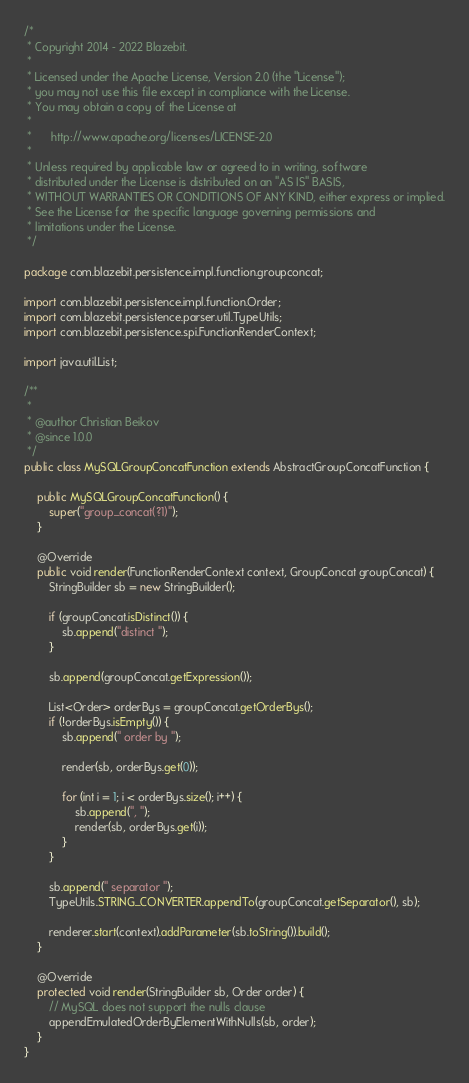Convert code to text. <code><loc_0><loc_0><loc_500><loc_500><_Java_>/*
 * Copyright 2014 - 2022 Blazebit.
 *
 * Licensed under the Apache License, Version 2.0 (the "License");
 * you may not use this file except in compliance with the License.
 * You may obtain a copy of the License at
 *
 *      http://www.apache.org/licenses/LICENSE-2.0
 *
 * Unless required by applicable law or agreed to in writing, software
 * distributed under the License is distributed on an "AS IS" BASIS,
 * WITHOUT WARRANTIES OR CONDITIONS OF ANY KIND, either express or implied.
 * See the License for the specific language governing permissions and
 * limitations under the License.
 */

package com.blazebit.persistence.impl.function.groupconcat;

import com.blazebit.persistence.impl.function.Order;
import com.blazebit.persistence.parser.util.TypeUtils;
import com.blazebit.persistence.spi.FunctionRenderContext;

import java.util.List;

/**
 *
 * @author Christian Beikov
 * @since 1.0.0
 */
public class MySQLGroupConcatFunction extends AbstractGroupConcatFunction {

    public MySQLGroupConcatFunction() {
        super("group_concat(?1)");
    }

    @Override
    public void render(FunctionRenderContext context, GroupConcat groupConcat) {
        StringBuilder sb = new StringBuilder();

        if (groupConcat.isDistinct()) {
            sb.append("distinct ");
        }

        sb.append(groupConcat.getExpression());

        List<Order> orderBys = groupConcat.getOrderBys();
        if (!orderBys.isEmpty()) {
            sb.append(" order by ");
            
            render(sb, orderBys.get(0));
            
            for (int i = 1; i < orderBys.size(); i++) {
                sb.append(", ");
                render(sb, orderBys.get(i));
            }
        }

        sb.append(" separator ");
        TypeUtils.STRING_CONVERTER.appendTo(groupConcat.getSeparator(), sb);

        renderer.start(context).addParameter(sb.toString()).build();
    }

    @Override
    protected void render(StringBuilder sb, Order order) {
        // MySQL does not support the nulls clause
        appendEmulatedOrderByElementWithNulls(sb, order);
    }
}
</code> 